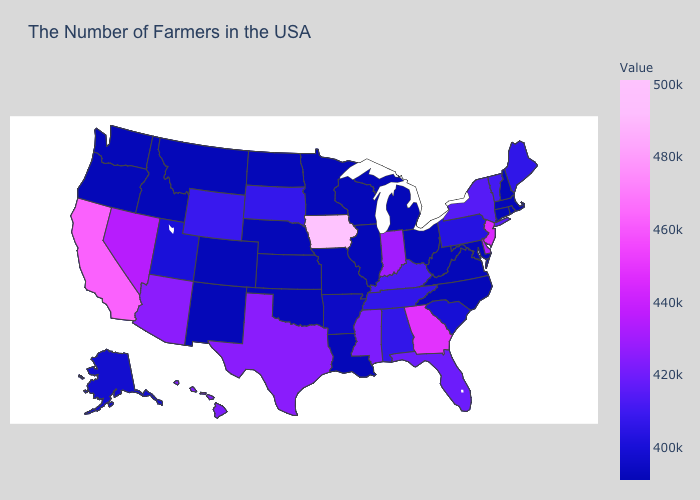Among the states that border Oregon , which have the highest value?
Write a very short answer. California. Does the map have missing data?
Keep it brief. No. Which states hav the highest value in the South?
Give a very brief answer. Georgia. Among the states that border Missouri , does Nebraska have the lowest value?
Answer briefly. Yes. Among the states that border Utah , which have the lowest value?
Keep it brief. Colorado, New Mexico, Idaho. Among the states that border Michigan , which have the highest value?
Quick response, please. Indiana. Among the states that border New Jersey , which have the highest value?
Short answer required. Delaware. Does Oklahoma have the lowest value in the USA?
Write a very short answer. Yes. Which states have the highest value in the USA?
Answer briefly. Iowa. Is the legend a continuous bar?
Be succinct. Yes. 